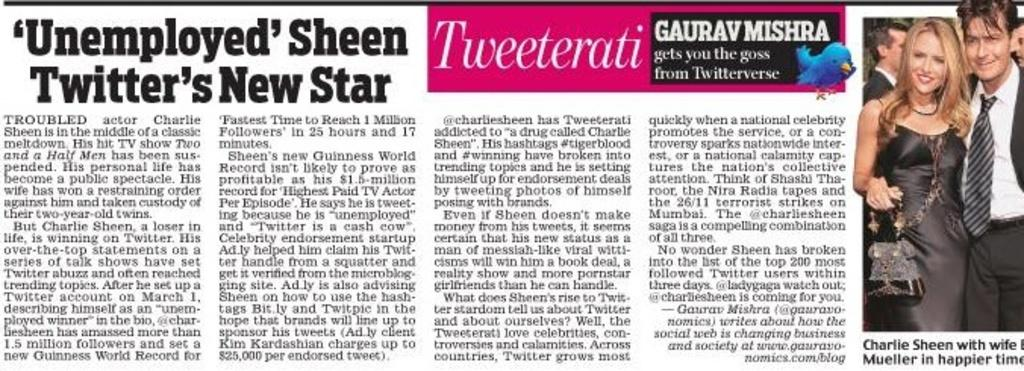What is the main subject of the image? The main subject of the image is an article. Can you describe any other elements in the image? Yes, there is a picture of people on the right side of the image. What color is the crayon used to draw the picture of people on the right side of the image? There is no crayon present in the image; the picture of people is likely a photograph or illustration. What type of relation can be observed between the people in the picture? The provided facts do not give any information about the relationship between the people in the picture, so it cannot be determined from the image. 